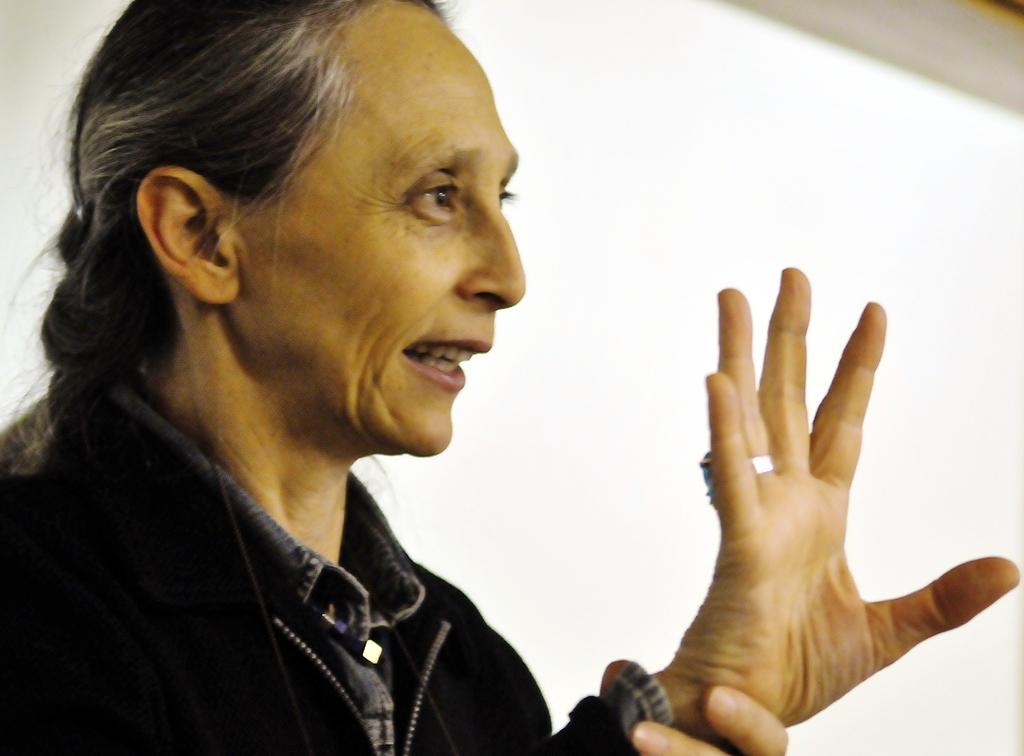How would you summarize this image in a sentence or two? There is a lady in the foreground area of the image. 